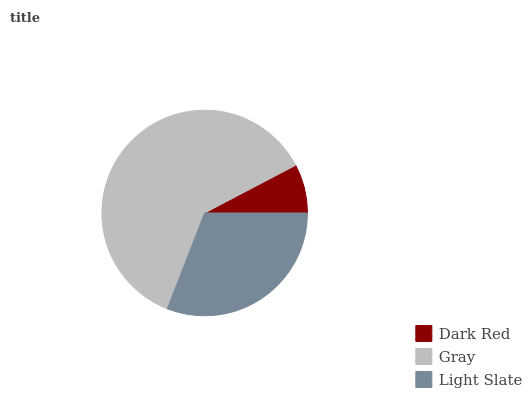Is Dark Red the minimum?
Answer yes or no. Yes. Is Gray the maximum?
Answer yes or no. Yes. Is Light Slate the minimum?
Answer yes or no. No. Is Light Slate the maximum?
Answer yes or no. No. Is Gray greater than Light Slate?
Answer yes or no. Yes. Is Light Slate less than Gray?
Answer yes or no. Yes. Is Light Slate greater than Gray?
Answer yes or no. No. Is Gray less than Light Slate?
Answer yes or no. No. Is Light Slate the high median?
Answer yes or no. Yes. Is Light Slate the low median?
Answer yes or no. Yes. Is Dark Red the high median?
Answer yes or no. No. Is Gray the low median?
Answer yes or no. No. 